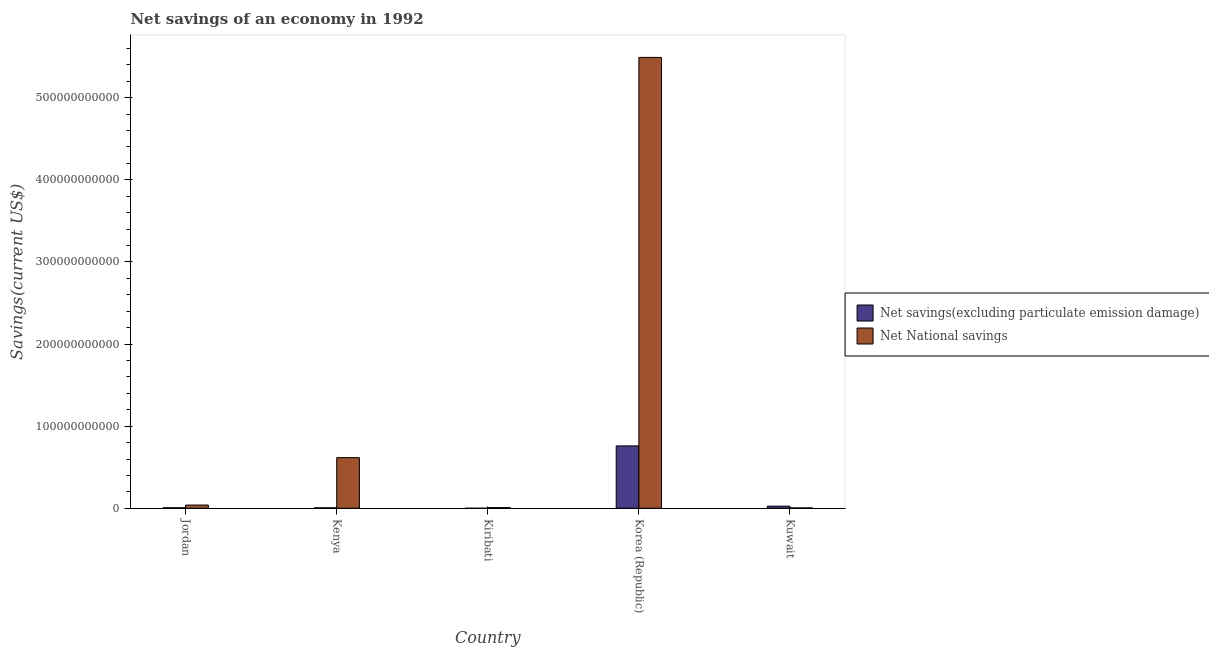How many different coloured bars are there?
Keep it short and to the point. 2. How many groups of bars are there?
Your answer should be compact. 5. Are the number of bars per tick equal to the number of legend labels?
Your answer should be very brief. Yes. Are the number of bars on each tick of the X-axis equal?
Offer a very short reply. Yes. How many bars are there on the 2nd tick from the left?
Provide a short and direct response. 2. What is the label of the 3rd group of bars from the left?
Provide a short and direct response. Kiribati. In how many cases, is the number of bars for a given country not equal to the number of legend labels?
Provide a short and direct response. 0. What is the net savings(excluding particulate emission damage) in Kenya?
Make the answer very short. 5.62e+08. Across all countries, what is the maximum net national savings?
Make the answer very short. 5.49e+11. Across all countries, what is the minimum net savings(excluding particulate emission damage)?
Your answer should be very brief. 2.35e+07. In which country was the net savings(excluding particulate emission damage) maximum?
Keep it short and to the point. Korea (Republic). In which country was the net savings(excluding particulate emission damage) minimum?
Keep it short and to the point. Kiribati. What is the total net national savings in the graph?
Give a very brief answer. 6.16e+11. What is the difference between the net savings(excluding particulate emission damage) in Jordan and that in Kuwait?
Your answer should be very brief. -1.94e+09. What is the difference between the net savings(excluding particulate emission damage) in Korea (Republic) and the net national savings in Kuwait?
Make the answer very short. 7.55e+1. What is the average net savings(excluding particulate emission damage) per country?
Your response must be concise. 1.60e+1. What is the difference between the net national savings and net savings(excluding particulate emission damage) in Korea (Republic)?
Provide a succinct answer. 4.73e+11. What is the ratio of the net savings(excluding particulate emission damage) in Jordan to that in Kenya?
Keep it short and to the point. 1.15. Is the difference between the net national savings in Kenya and Kiribati greater than the difference between the net savings(excluding particulate emission damage) in Kenya and Kiribati?
Your answer should be very brief. Yes. What is the difference between the highest and the second highest net savings(excluding particulate emission damage)?
Ensure brevity in your answer.  7.34e+1. What is the difference between the highest and the lowest net savings(excluding particulate emission damage)?
Keep it short and to the point. 7.59e+1. In how many countries, is the net national savings greater than the average net national savings taken over all countries?
Your answer should be compact. 1. What does the 2nd bar from the left in Kiribati represents?
Offer a very short reply. Net National savings. What does the 1st bar from the right in Kiribati represents?
Your response must be concise. Net National savings. Are all the bars in the graph horizontal?
Your answer should be very brief. No. What is the difference between two consecutive major ticks on the Y-axis?
Your answer should be very brief. 1.00e+11. Does the graph contain any zero values?
Ensure brevity in your answer.  No. Does the graph contain grids?
Your answer should be compact. No. What is the title of the graph?
Provide a short and direct response. Net savings of an economy in 1992. Does "Public funds" appear as one of the legend labels in the graph?
Give a very brief answer. No. What is the label or title of the X-axis?
Your response must be concise. Country. What is the label or title of the Y-axis?
Your answer should be very brief. Savings(current US$). What is the Savings(current US$) of Net savings(excluding particulate emission damage) in Jordan?
Keep it short and to the point. 6.44e+08. What is the Savings(current US$) of Net National savings in Jordan?
Give a very brief answer. 3.93e+09. What is the Savings(current US$) in Net savings(excluding particulate emission damage) in Kenya?
Provide a succinct answer. 5.62e+08. What is the Savings(current US$) of Net National savings in Kenya?
Make the answer very short. 6.17e+1. What is the Savings(current US$) in Net savings(excluding particulate emission damage) in Kiribati?
Your answer should be compact. 2.35e+07. What is the Savings(current US$) of Net National savings in Kiribati?
Give a very brief answer. 8.23e+08. What is the Savings(current US$) of Net savings(excluding particulate emission damage) in Korea (Republic)?
Provide a succinct answer. 7.60e+1. What is the Savings(current US$) in Net National savings in Korea (Republic)?
Your answer should be compact. 5.49e+11. What is the Savings(current US$) in Net savings(excluding particulate emission damage) in Kuwait?
Offer a very short reply. 2.58e+09. What is the Savings(current US$) in Net National savings in Kuwait?
Make the answer very short. 4.66e+08. Across all countries, what is the maximum Savings(current US$) of Net savings(excluding particulate emission damage)?
Provide a short and direct response. 7.60e+1. Across all countries, what is the maximum Savings(current US$) in Net National savings?
Give a very brief answer. 5.49e+11. Across all countries, what is the minimum Savings(current US$) in Net savings(excluding particulate emission damage)?
Your response must be concise. 2.35e+07. Across all countries, what is the minimum Savings(current US$) in Net National savings?
Your answer should be very brief. 4.66e+08. What is the total Savings(current US$) in Net savings(excluding particulate emission damage) in the graph?
Offer a very short reply. 7.98e+1. What is the total Savings(current US$) in Net National savings in the graph?
Your answer should be very brief. 6.16e+11. What is the difference between the Savings(current US$) in Net savings(excluding particulate emission damage) in Jordan and that in Kenya?
Give a very brief answer. 8.18e+07. What is the difference between the Savings(current US$) in Net National savings in Jordan and that in Kenya?
Ensure brevity in your answer.  -5.77e+1. What is the difference between the Savings(current US$) in Net savings(excluding particulate emission damage) in Jordan and that in Kiribati?
Keep it short and to the point. 6.20e+08. What is the difference between the Savings(current US$) of Net National savings in Jordan and that in Kiribati?
Make the answer very short. 3.10e+09. What is the difference between the Savings(current US$) of Net savings(excluding particulate emission damage) in Jordan and that in Korea (Republic)?
Your answer should be compact. -7.53e+1. What is the difference between the Savings(current US$) in Net National savings in Jordan and that in Korea (Republic)?
Your answer should be very brief. -5.45e+11. What is the difference between the Savings(current US$) of Net savings(excluding particulate emission damage) in Jordan and that in Kuwait?
Your answer should be very brief. -1.94e+09. What is the difference between the Savings(current US$) of Net National savings in Jordan and that in Kuwait?
Keep it short and to the point. 3.46e+09. What is the difference between the Savings(current US$) in Net savings(excluding particulate emission damage) in Kenya and that in Kiribati?
Ensure brevity in your answer.  5.38e+08. What is the difference between the Savings(current US$) of Net National savings in Kenya and that in Kiribati?
Keep it short and to the point. 6.08e+1. What is the difference between the Savings(current US$) in Net savings(excluding particulate emission damage) in Kenya and that in Korea (Republic)?
Ensure brevity in your answer.  -7.54e+1. What is the difference between the Savings(current US$) in Net National savings in Kenya and that in Korea (Republic)?
Ensure brevity in your answer.  -4.87e+11. What is the difference between the Savings(current US$) in Net savings(excluding particulate emission damage) in Kenya and that in Kuwait?
Provide a succinct answer. -2.02e+09. What is the difference between the Savings(current US$) in Net National savings in Kenya and that in Kuwait?
Give a very brief answer. 6.12e+1. What is the difference between the Savings(current US$) in Net savings(excluding particulate emission damage) in Kiribati and that in Korea (Republic)?
Make the answer very short. -7.59e+1. What is the difference between the Savings(current US$) of Net National savings in Kiribati and that in Korea (Republic)?
Make the answer very short. -5.48e+11. What is the difference between the Savings(current US$) in Net savings(excluding particulate emission damage) in Kiribati and that in Kuwait?
Give a very brief answer. -2.56e+09. What is the difference between the Savings(current US$) of Net National savings in Kiribati and that in Kuwait?
Keep it short and to the point. 3.57e+08. What is the difference between the Savings(current US$) of Net savings(excluding particulate emission damage) in Korea (Republic) and that in Kuwait?
Keep it short and to the point. 7.34e+1. What is the difference between the Savings(current US$) in Net National savings in Korea (Republic) and that in Kuwait?
Ensure brevity in your answer.  5.49e+11. What is the difference between the Savings(current US$) in Net savings(excluding particulate emission damage) in Jordan and the Savings(current US$) in Net National savings in Kenya?
Provide a short and direct response. -6.10e+1. What is the difference between the Savings(current US$) in Net savings(excluding particulate emission damage) in Jordan and the Savings(current US$) in Net National savings in Kiribati?
Give a very brief answer. -1.79e+08. What is the difference between the Savings(current US$) of Net savings(excluding particulate emission damage) in Jordan and the Savings(current US$) of Net National savings in Korea (Republic)?
Ensure brevity in your answer.  -5.48e+11. What is the difference between the Savings(current US$) in Net savings(excluding particulate emission damage) in Jordan and the Savings(current US$) in Net National savings in Kuwait?
Ensure brevity in your answer.  1.78e+08. What is the difference between the Savings(current US$) of Net savings(excluding particulate emission damage) in Kenya and the Savings(current US$) of Net National savings in Kiribati?
Your answer should be compact. -2.61e+08. What is the difference between the Savings(current US$) in Net savings(excluding particulate emission damage) in Kenya and the Savings(current US$) in Net National savings in Korea (Republic)?
Offer a very short reply. -5.48e+11. What is the difference between the Savings(current US$) of Net savings(excluding particulate emission damage) in Kenya and the Savings(current US$) of Net National savings in Kuwait?
Provide a succinct answer. 9.58e+07. What is the difference between the Savings(current US$) of Net savings(excluding particulate emission damage) in Kiribati and the Savings(current US$) of Net National savings in Korea (Republic)?
Provide a short and direct response. -5.49e+11. What is the difference between the Savings(current US$) in Net savings(excluding particulate emission damage) in Kiribati and the Savings(current US$) in Net National savings in Kuwait?
Ensure brevity in your answer.  -4.43e+08. What is the difference between the Savings(current US$) in Net savings(excluding particulate emission damage) in Korea (Republic) and the Savings(current US$) in Net National savings in Kuwait?
Provide a succinct answer. 7.55e+1. What is the average Savings(current US$) of Net savings(excluding particulate emission damage) per country?
Your response must be concise. 1.60e+1. What is the average Savings(current US$) of Net National savings per country?
Your response must be concise. 1.23e+11. What is the difference between the Savings(current US$) of Net savings(excluding particulate emission damage) and Savings(current US$) of Net National savings in Jordan?
Give a very brief answer. -3.28e+09. What is the difference between the Savings(current US$) in Net savings(excluding particulate emission damage) and Savings(current US$) in Net National savings in Kenya?
Give a very brief answer. -6.11e+1. What is the difference between the Savings(current US$) in Net savings(excluding particulate emission damage) and Savings(current US$) in Net National savings in Kiribati?
Ensure brevity in your answer.  -7.99e+08. What is the difference between the Savings(current US$) of Net savings(excluding particulate emission damage) and Savings(current US$) of Net National savings in Korea (Republic)?
Your answer should be very brief. -4.73e+11. What is the difference between the Savings(current US$) of Net savings(excluding particulate emission damage) and Savings(current US$) of Net National savings in Kuwait?
Provide a short and direct response. 2.11e+09. What is the ratio of the Savings(current US$) of Net savings(excluding particulate emission damage) in Jordan to that in Kenya?
Your response must be concise. 1.15. What is the ratio of the Savings(current US$) of Net National savings in Jordan to that in Kenya?
Your response must be concise. 0.06. What is the ratio of the Savings(current US$) in Net savings(excluding particulate emission damage) in Jordan to that in Kiribati?
Your answer should be very brief. 27.45. What is the ratio of the Savings(current US$) in Net National savings in Jordan to that in Kiribati?
Your answer should be very brief. 4.77. What is the ratio of the Savings(current US$) of Net savings(excluding particulate emission damage) in Jordan to that in Korea (Republic)?
Your answer should be very brief. 0.01. What is the ratio of the Savings(current US$) in Net National savings in Jordan to that in Korea (Republic)?
Offer a very short reply. 0.01. What is the ratio of the Savings(current US$) in Net savings(excluding particulate emission damage) in Jordan to that in Kuwait?
Offer a very short reply. 0.25. What is the ratio of the Savings(current US$) in Net National savings in Jordan to that in Kuwait?
Give a very brief answer. 8.42. What is the ratio of the Savings(current US$) of Net savings(excluding particulate emission damage) in Kenya to that in Kiribati?
Your answer should be very brief. 23.96. What is the ratio of the Savings(current US$) of Net National savings in Kenya to that in Kiribati?
Provide a succinct answer. 74.94. What is the ratio of the Savings(current US$) in Net savings(excluding particulate emission damage) in Kenya to that in Korea (Republic)?
Provide a succinct answer. 0.01. What is the ratio of the Savings(current US$) of Net National savings in Kenya to that in Korea (Republic)?
Ensure brevity in your answer.  0.11. What is the ratio of the Savings(current US$) in Net savings(excluding particulate emission damage) in Kenya to that in Kuwait?
Provide a short and direct response. 0.22. What is the ratio of the Savings(current US$) of Net National savings in Kenya to that in Kuwait?
Ensure brevity in your answer.  132.27. What is the ratio of the Savings(current US$) of Net National savings in Kiribati to that in Korea (Republic)?
Offer a very short reply. 0. What is the ratio of the Savings(current US$) in Net savings(excluding particulate emission damage) in Kiribati to that in Kuwait?
Ensure brevity in your answer.  0.01. What is the ratio of the Savings(current US$) in Net National savings in Kiribati to that in Kuwait?
Provide a short and direct response. 1.76. What is the ratio of the Savings(current US$) of Net savings(excluding particulate emission damage) in Korea (Republic) to that in Kuwait?
Keep it short and to the point. 29.46. What is the ratio of the Savings(current US$) of Net National savings in Korea (Republic) to that in Kuwait?
Your answer should be compact. 1177.84. What is the difference between the highest and the second highest Savings(current US$) in Net savings(excluding particulate emission damage)?
Offer a very short reply. 7.34e+1. What is the difference between the highest and the second highest Savings(current US$) of Net National savings?
Provide a succinct answer. 4.87e+11. What is the difference between the highest and the lowest Savings(current US$) of Net savings(excluding particulate emission damage)?
Your answer should be compact. 7.59e+1. What is the difference between the highest and the lowest Savings(current US$) in Net National savings?
Your response must be concise. 5.49e+11. 